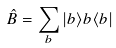Convert formula to latex. <formula><loc_0><loc_0><loc_500><loc_500>\hat { B } = \sum _ { b } | b \rangle b \langle b |</formula> 